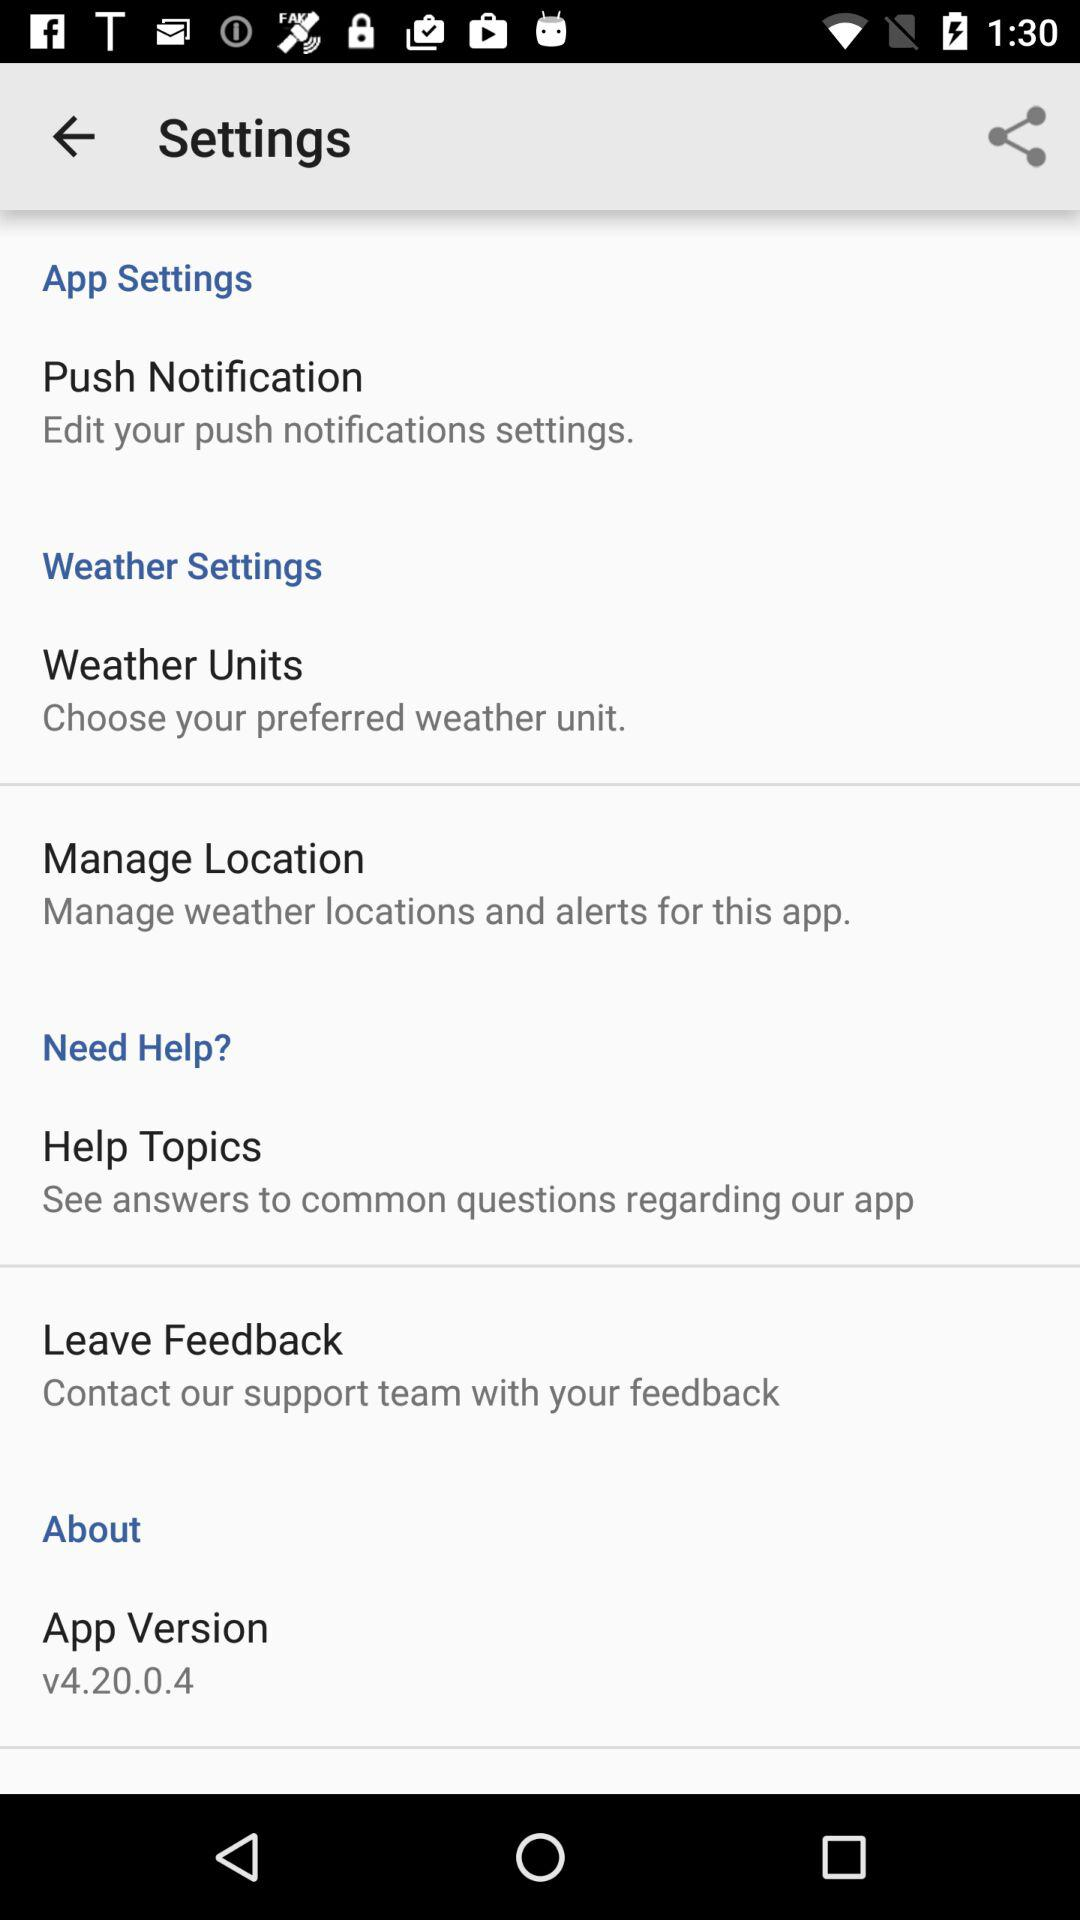How many of the settings are about weather?
Answer the question using a single word or phrase. 2 